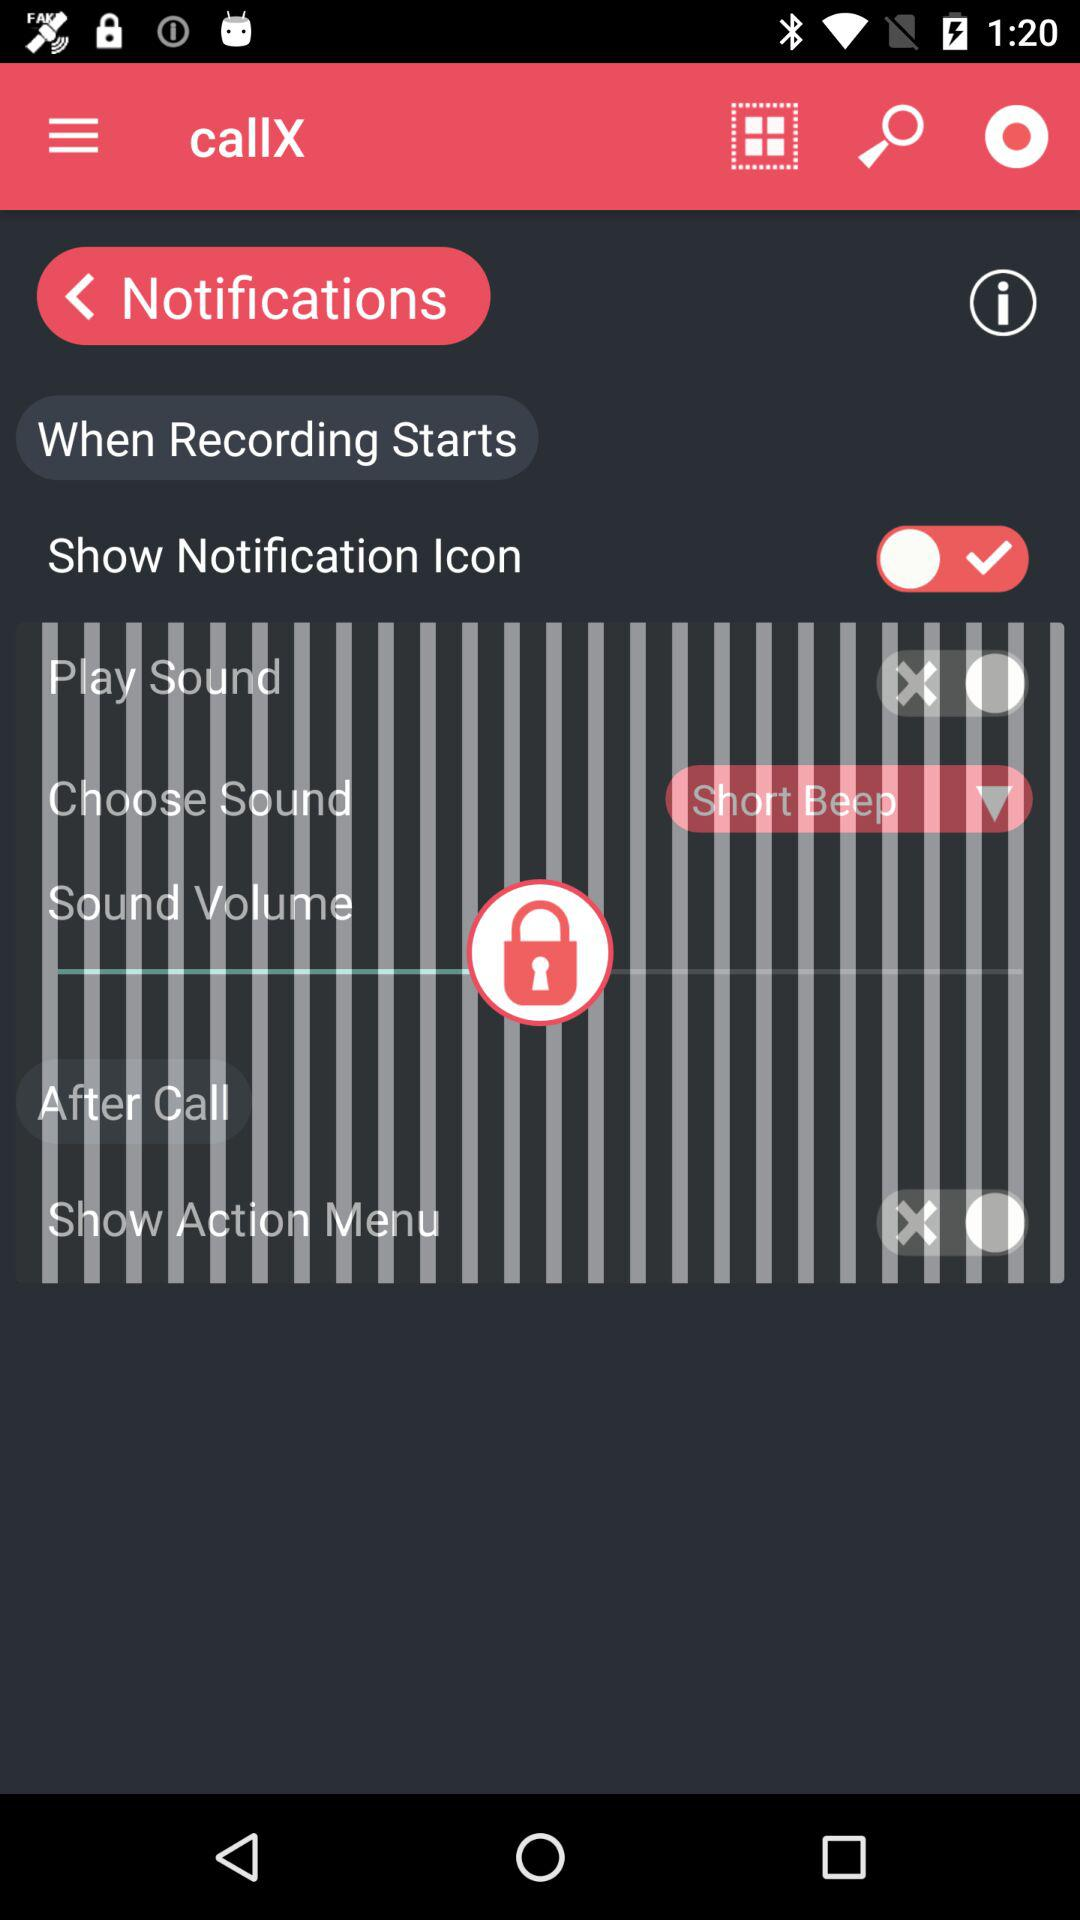How loud is the sound?
When the provided information is insufficient, respond with <no answer>. <no answer> 